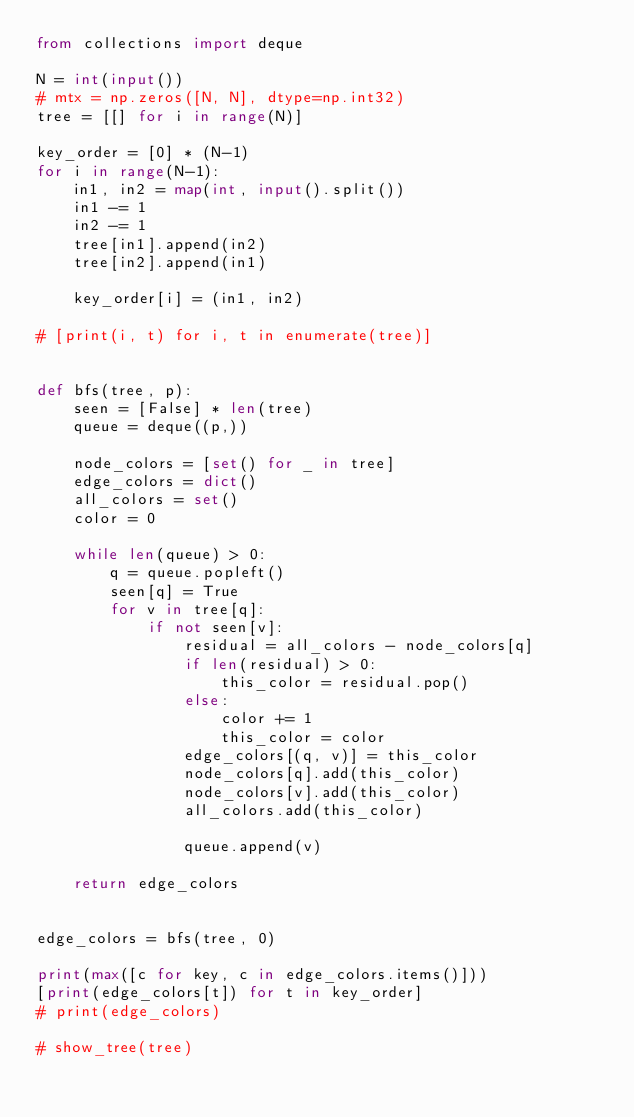Convert code to text. <code><loc_0><loc_0><loc_500><loc_500><_Python_>from collections import deque

N = int(input())
# mtx = np.zeros([N, N], dtype=np.int32)
tree = [[] for i in range(N)]

key_order = [0] * (N-1)
for i in range(N-1):
    in1, in2 = map(int, input().split())
    in1 -= 1
    in2 -= 1
    tree[in1].append(in2)
    tree[in2].append(in1)

    key_order[i] = (in1, in2)

# [print(i, t) for i, t in enumerate(tree)]


def bfs(tree, p):
    seen = [False] * len(tree)
    queue = deque((p,))

    node_colors = [set() for _ in tree]
    edge_colors = dict()
    all_colors = set()
    color = 0

    while len(queue) > 0:
        q = queue.popleft()
        seen[q] = True
        for v in tree[q]:
            if not seen[v]:
                residual = all_colors - node_colors[q]
                if len(residual) > 0:
                    this_color = residual.pop()
                else:
                    color += 1
                    this_color = color
                edge_colors[(q, v)] = this_color
                node_colors[q].add(this_color)
                node_colors[v].add(this_color)
                all_colors.add(this_color)

                queue.append(v)

    return edge_colors


edge_colors = bfs(tree, 0)

print(max([c for key, c in edge_colors.items()]))
[print(edge_colors[t]) for t in key_order]
# print(edge_colors)

# show_tree(tree)
</code> 